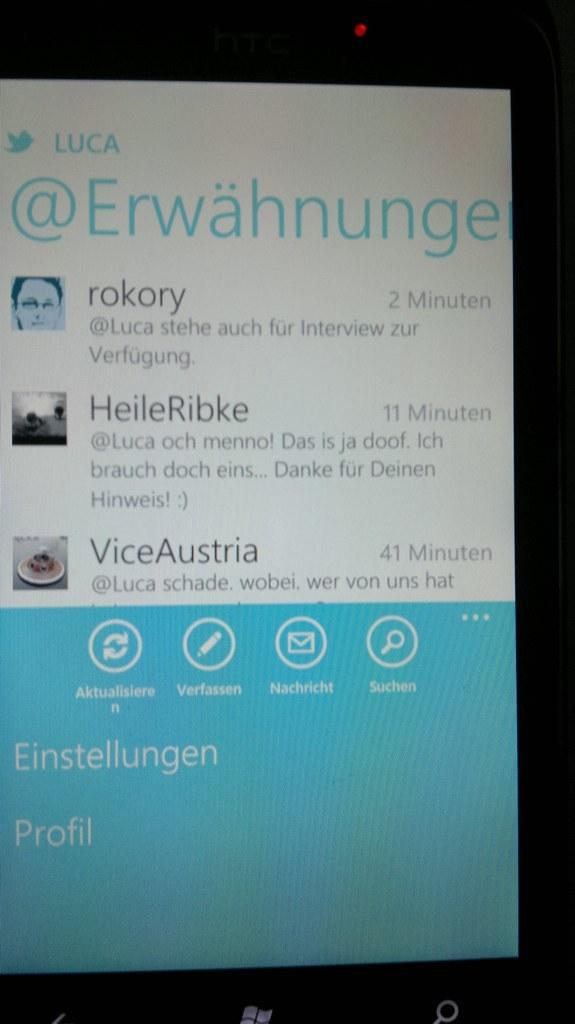<image>
Give a short and clear explanation of the subsequent image. The screen of a tablet showing @Erwahnunge twitter page 